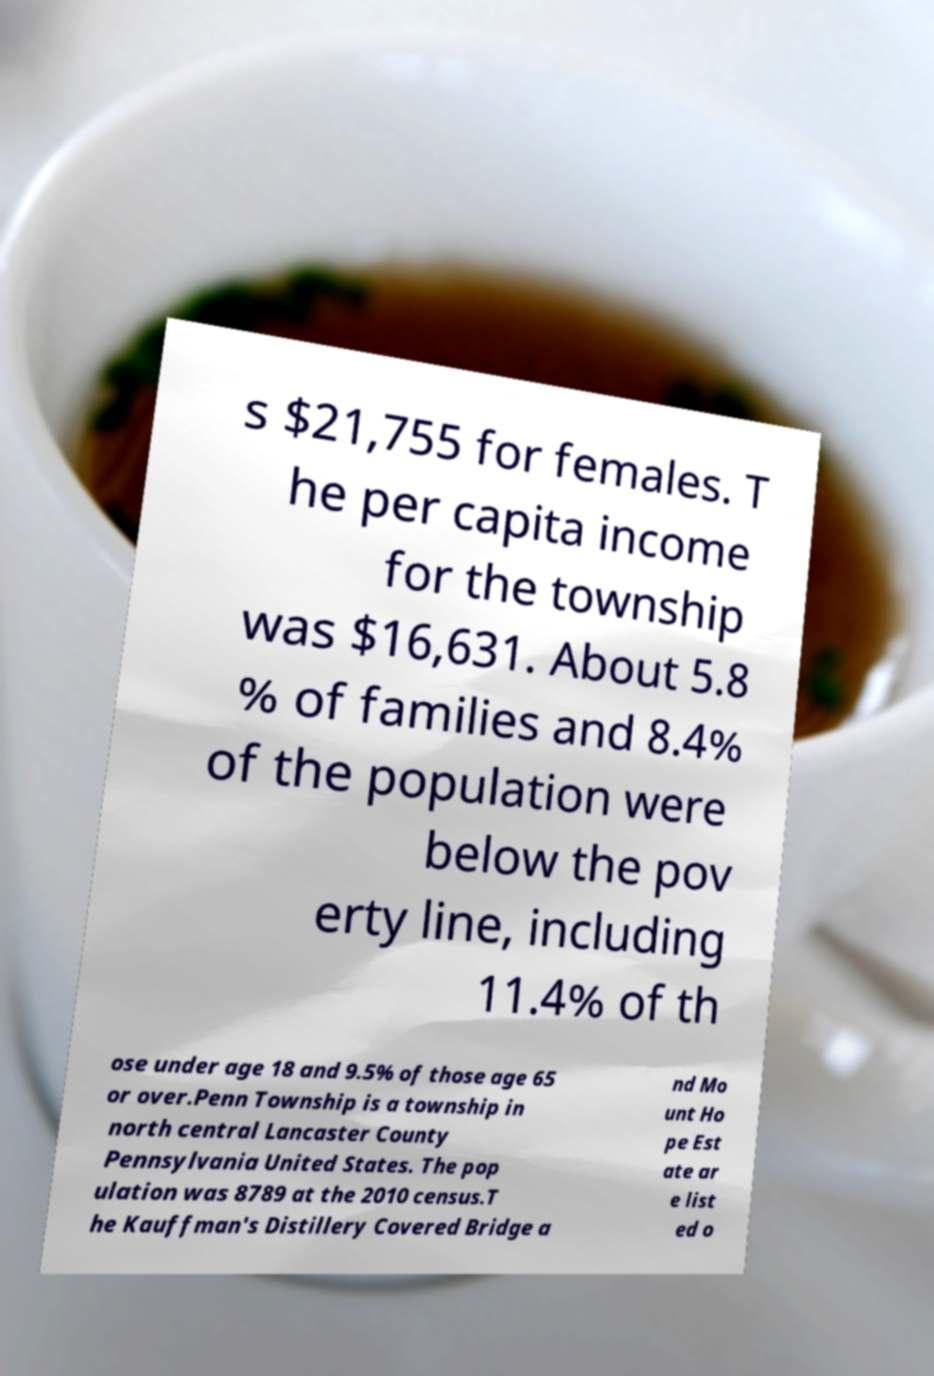Please identify and transcribe the text found in this image. s $21,755 for females. T he per capita income for the township was $16,631. About 5.8 % of families and 8.4% of the population were below the pov erty line, including 11.4% of th ose under age 18 and 9.5% of those age 65 or over.Penn Township is a township in north central Lancaster County Pennsylvania United States. The pop ulation was 8789 at the 2010 census.T he Kauffman's Distillery Covered Bridge a nd Mo unt Ho pe Est ate ar e list ed o 